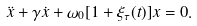<formula> <loc_0><loc_0><loc_500><loc_500>\ddot { x } + \gamma \dot { x } + \omega _ { 0 } [ 1 + \xi _ { \tau } ( t ) ] x = 0 .</formula> 